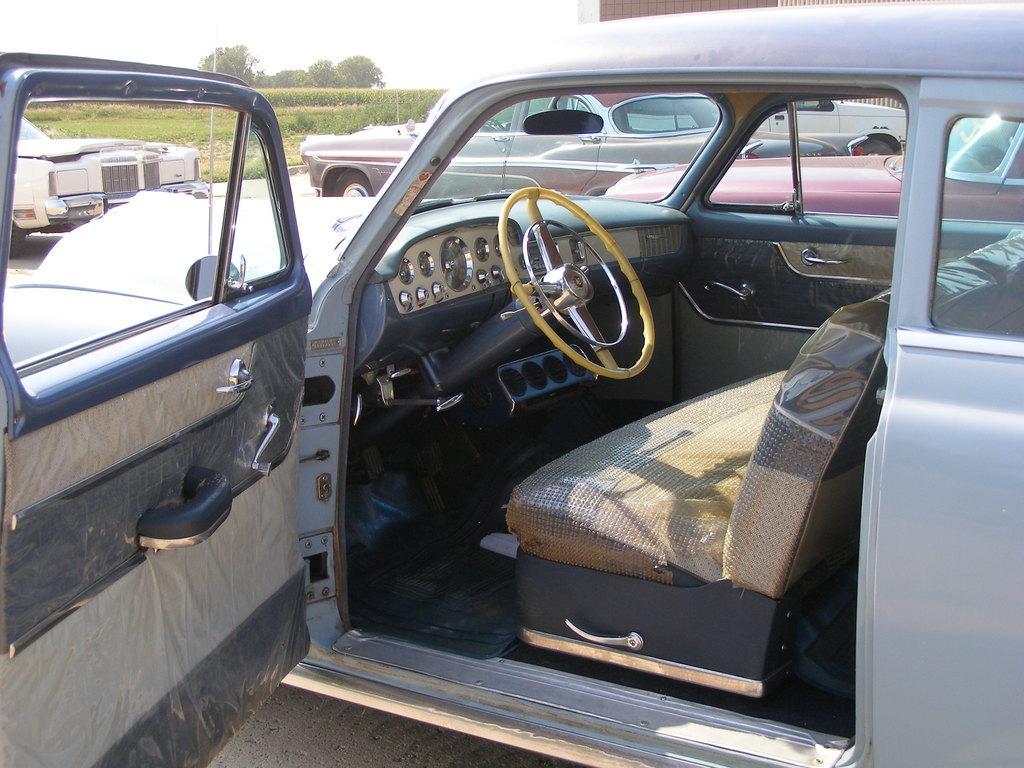Can you describe this image briefly? In this image we can see vehicles, grass, plants, trees, we can see the sky. 